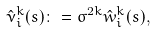Convert formula to latex. <formula><loc_0><loc_0><loc_500><loc_500>\hat { \nu } _ { i } ^ { k } ( s ) \colon = \sigma ^ { 2 k } \hat { w } _ { i } ^ { k } ( s ) ,</formula> 